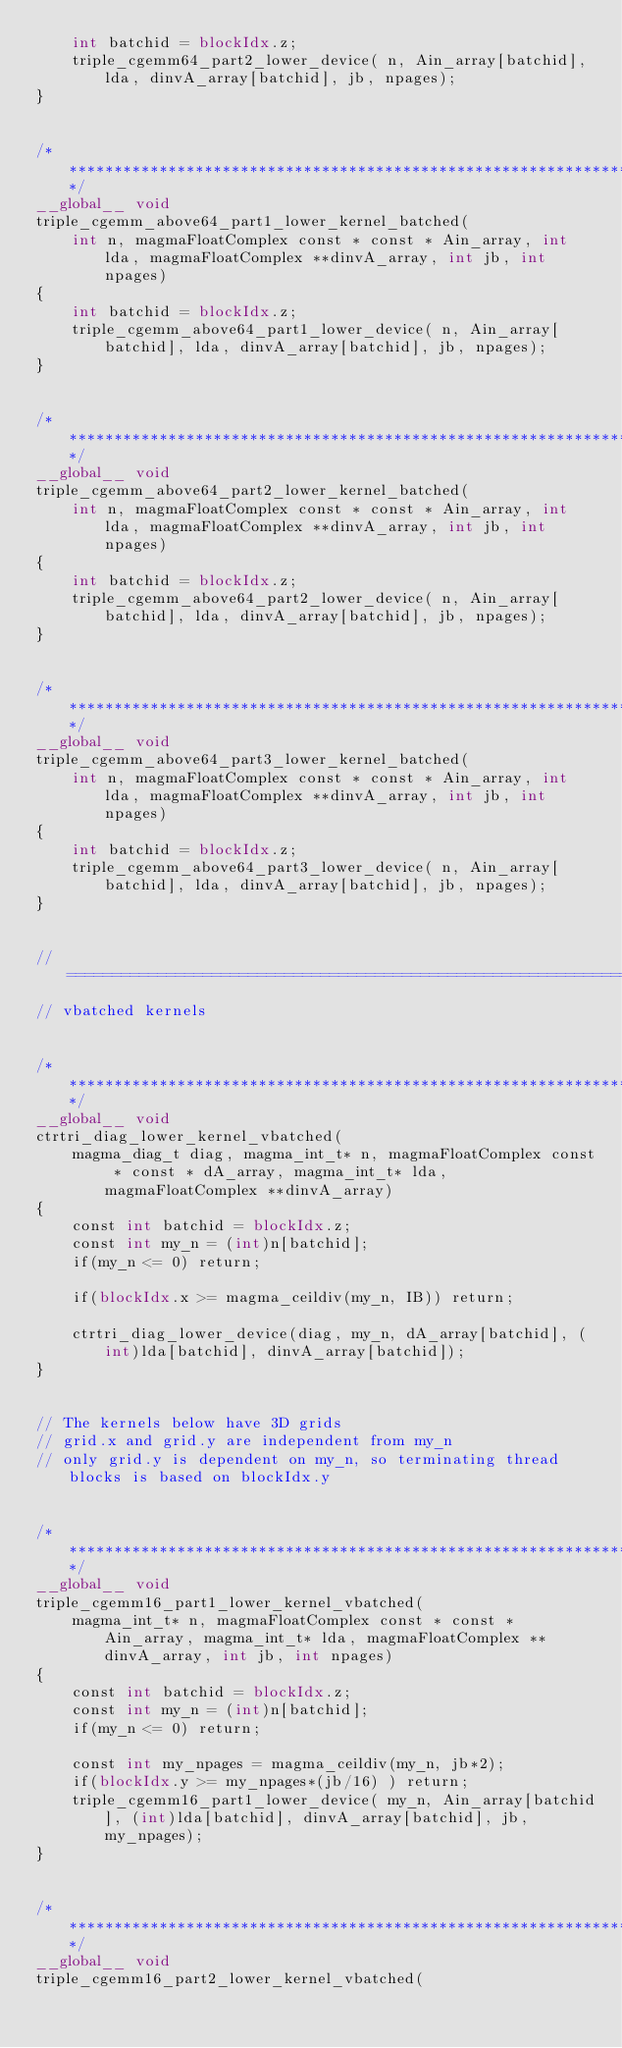<code> <loc_0><loc_0><loc_500><loc_500><_Cuda_>    int batchid = blockIdx.z;
    triple_cgemm64_part2_lower_device( n, Ain_array[batchid], lda, dinvA_array[batchid], jb, npages);
}


/******************************************************************************/
__global__ void
triple_cgemm_above64_part1_lower_kernel_batched(
    int n, magmaFloatComplex const * const * Ain_array, int lda, magmaFloatComplex **dinvA_array, int jb, int npages)
{
    int batchid = blockIdx.z;
    triple_cgemm_above64_part1_lower_device( n, Ain_array[batchid], lda, dinvA_array[batchid], jb, npages);
}


/******************************************************************************/
__global__ void
triple_cgemm_above64_part2_lower_kernel_batched(
    int n, magmaFloatComplex const * const * Ain_array, int lda, magmaFloatComplex **dinvA_array, int jb, int npages)
{
    int batchid = blockIdx.z;
    triple_cgemm_above64_part2_lower_device( n, Ain_array[batchid], lda, dinvA_array[batchid], jb, npages);
}


/******************************************************************************/
__global__ void
triple_cgemm_above64_part3_lower_kernel_batched(
    int n, magmaFloatComplex const * const * Ain_array, int lda, magmaFloatComplex **dinvA_array, int jb, int npages)
{
    int batchid = blockIdx.z;
    triple_cgemm_above64_part3_lower_device( n, Ain_array[batchid], lda, dinvA_array[batchid], jb, npages);
}


// =============================================================================
// vbatched kernels


/******************************************************************************/
__global__ void
ctrtri_diag_lower_kernel_vbatched(
    magma_diag_t diag, magma_int_t* n, magmaFloatComplex const * const * dA_array, magma_int_t* lda, magmaFloatComplex **dinvA_array)
{
    const int batchid = blockIdx.z;
    const int my_n = (int)n[batchid];
    if(my_n <= 0) return; 
    
    if(blockIdx.x >= magma_ceildiv(my_n, IB)) return;
    
    ctrtri_diag_lower_device(diag, my_n, dA_array[batchid], (int)lda[batchid], dinvA_array[batchid]);
}


// The kernels below have 3D grids
// grid.x and grid.y are independent from my_n
// only grid.y is dependent on my_n, so terminating thread blocks is based on blockIdx.y


/******************************************************************************/
__global__ void
triple_cgemm16_part1_lower_kernel_vbatched(
    magma_int_t* n, magmaFloatComplex const * const * Ain_array, magma_int_t* lda, magmaFloatComplex **dinvA_array, int jb, int npages)
{
    const int batchid = blockIdx.z;
    const int my_n = (int)n[batchid];
    if(my_n <= 0) return;
    
    const int my_npages = magma_ceildiv(my_n, jb*2);
    if(blockIdx.y >= my_npages*(jb/16) ) return;
    triple_cgemm16_part1_lower_device( my_n, Ain_array[batchid], (int)lda[batchid], dinvA_array[batchid], jb, my_npages);
}


/******************************************************************************/
__global__ void
triple_cgemm16_part2_lower_kernel_vbatched(</code> 